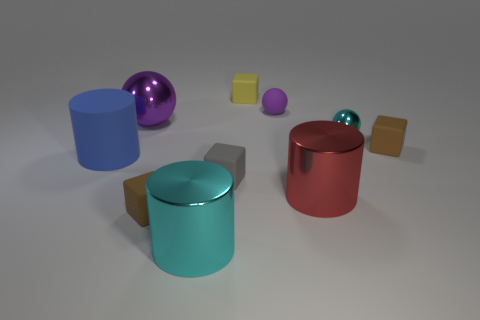Subtract all big metal spheres. How many spheres are left? 2 Subtract all cyan cubes. Subtract all blue cylinders. How many cubes are left? 4 Subtract all balls. How many objects are left? 7 Add 3 yellow cubes. How many yellow cubes are left? 4 Add 2 small rubber cubes. How many small rubber cubes exist? 6 Subtract 0 red blocks. How many objects are left? 10 Subtract all metallic blocks. Subtract all rubber things. How many objects are left? 4 